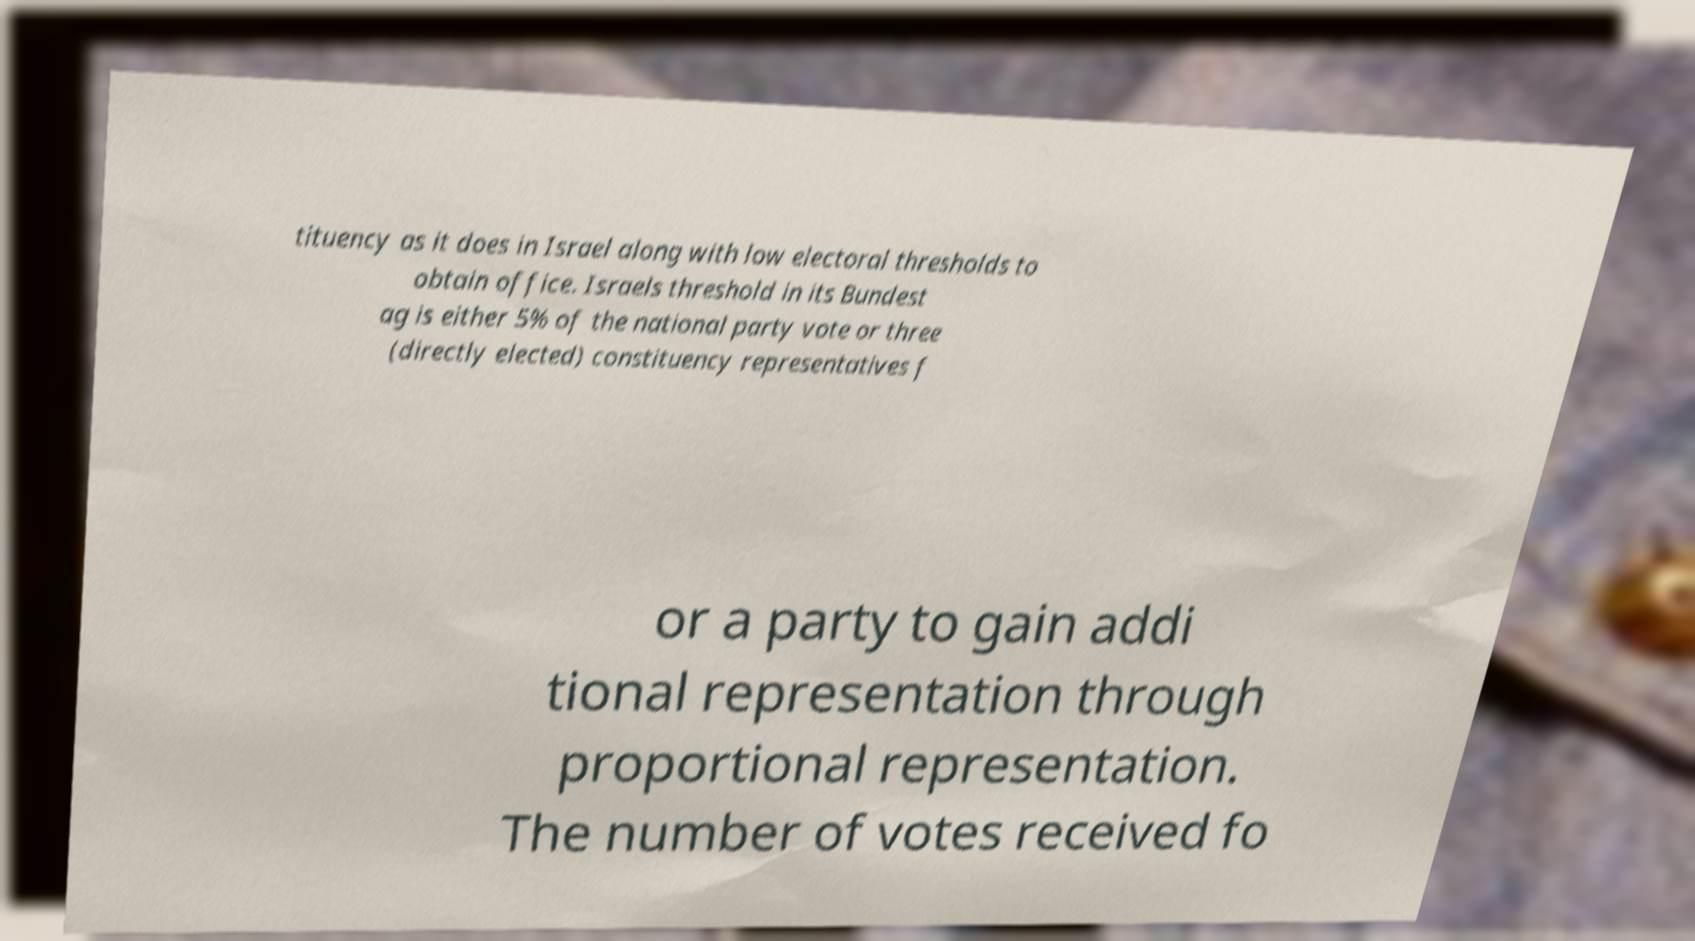There's text embedded in this image that I need extracted. Can you transcribe it verbatim? tituency as it does in Israel along with low electoral thresholds to obtain office. Israels threshold in its Bundest ag is either 5% of the national party vote or three (directly elected) constituency representatives f or a party to gain addi tional representation through proportional representation. The number of votes received fo 